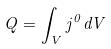<formula> <loc_0><loc_0><loc_500><loc_500>Q = \int _ { V } j ^ { 0 } d V</formula> 